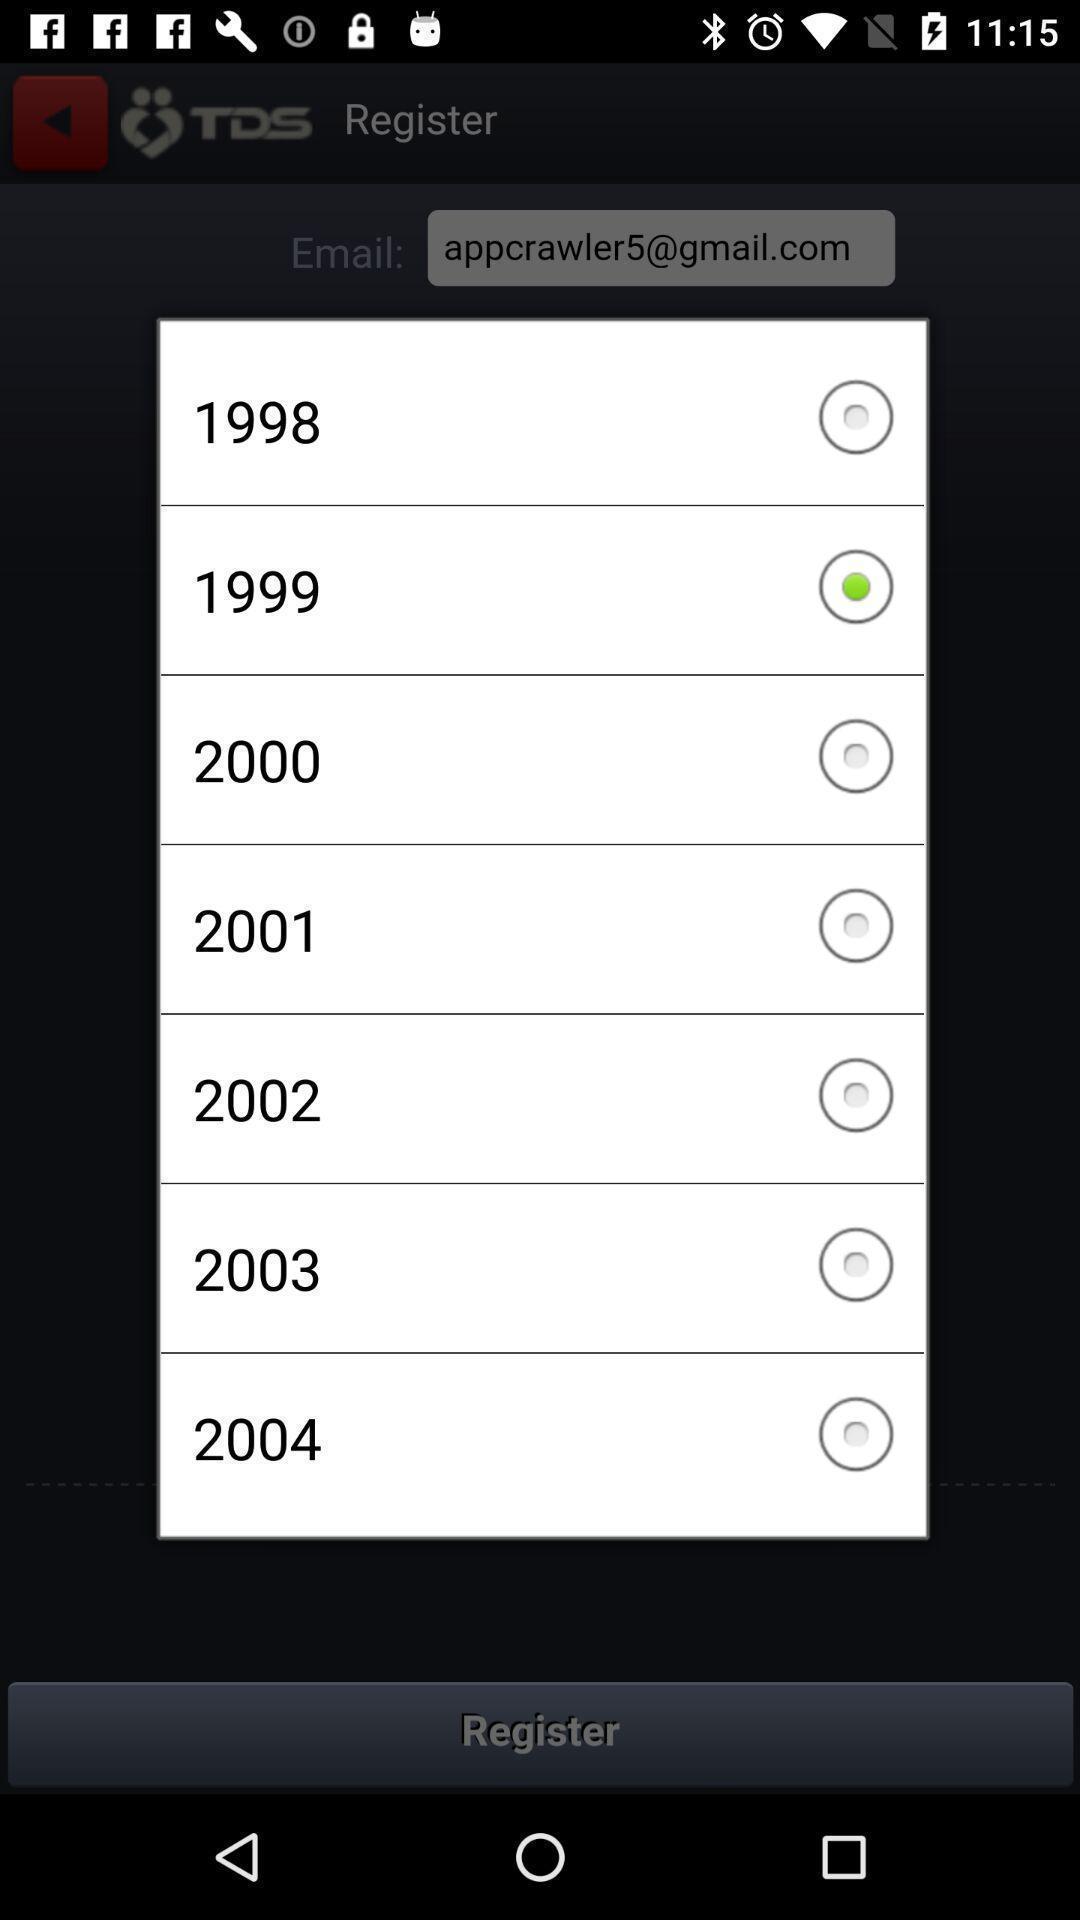What details can you identify in this image? Pop-up showing list of years. 